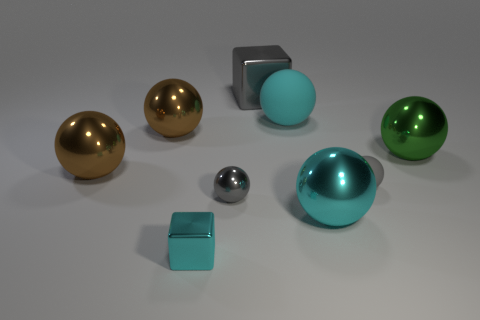Subtract all gray cubes. How many cubes are left? 1 Subtract all big matte balls. How many balls are left? 6 Subtract all blocks. How many objects are left? 7 Subtract 3 spheres. How many spheres are left? 4 Add 3 yellow objects. How many yellow objects exist? 3 Subtract 0 purple spheres. How many objects are left? 9 Subtract all purple balls. Subtract all purple cylinders. How many balls are left? 7 Subtract all purple cubes. How many cyan spheres are left? 2 Subtract all large brown things. Subtract all cyan matte things. How many objects are left? 6 Add 8 big cubes. How many big cubes are left? 9 